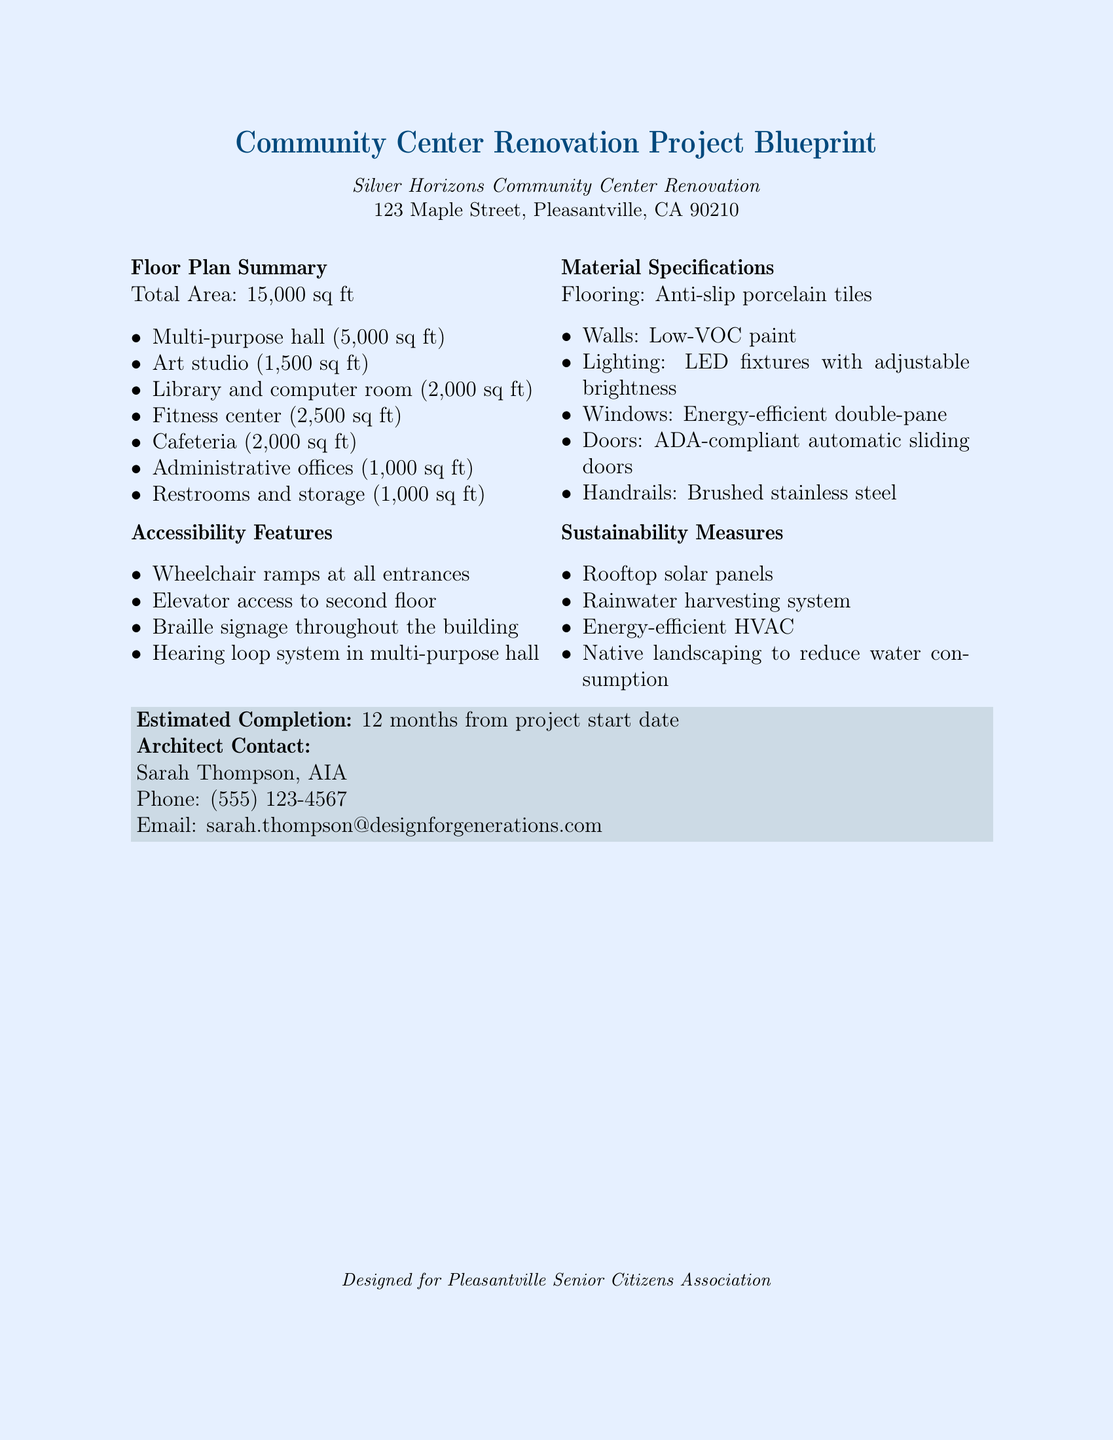What is the total area of the community center? The total area is stated in the document as 15,000 sq ft.
Answer: 15,000 sq ft How many square feet is the fitness center? The document lists the area of the fitness center as 2,500 sq ft.
Answer: 2,500 sq ft What type of tiles will be used for flooring? The flooring material specified is anti-slip porcelain tiles.
Answer: Anti-slip porcelain tiles What is one sustainability measure mentioned in the document? The document mentions rooftop solar panels as a sustainability measure.
Answer: Rooftop solar panels Who is the architect for the project? The architect's name, as per the document, is Sarah Thompson.
Answer: Sarah Thompson What feature provides accessibility for wheelchairs? The document states that wheelchair ramps at all entrances provide accessibility.
Answer: Wheelchair ramps What is the estimated completion time of the project? The estimated completion time is clearly stated as 12 months from project start date.
Answer: 12 months What type of lighting is specified for the renovation? The document specifies LED fixtures with adjustable brightness for lighting.
Answer: LED fixtures with adjustable brightness How many restrooms and storage areas are included in the plan? The document indicates that there are 1,000 sq ft allocated for restrooms and storage.
Answer: 1,000 sq ft 